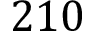Convert formula to latex. <formula><loc_0><loc_0><loc_500><loc_500>2 1 0</formula> 